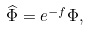Convert formula to latex. <formula><loc_0><loc_0><loc_500><loc_500>\widehat { \Phi } = e ^ { - f } \Phi ,</formula> 